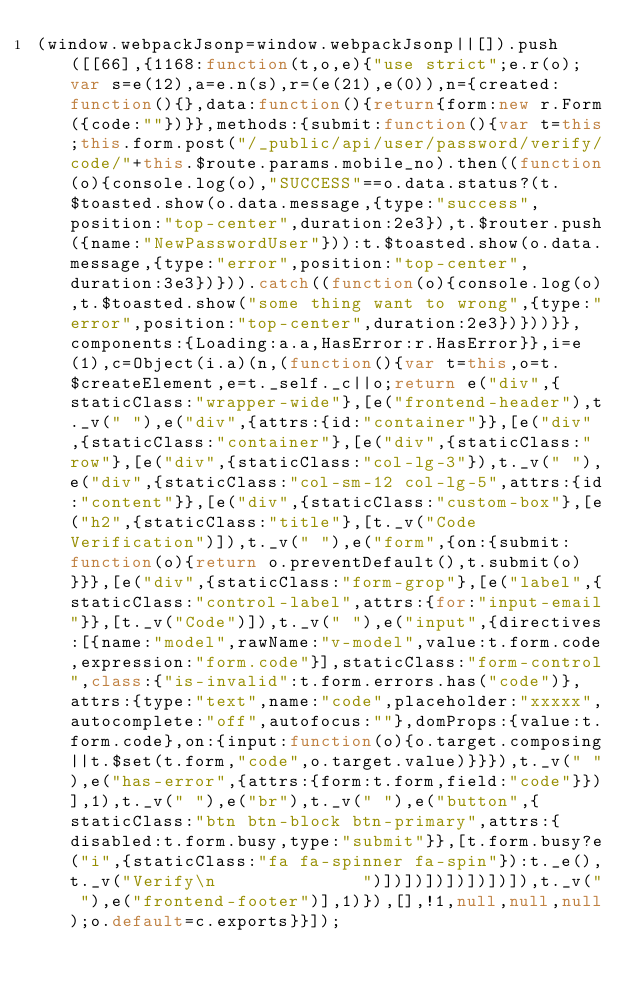Convert code to text. <code><loc_0><loc_0><loc_500><loc_500><_JavaScript_>(window.webpackJsonp=window.webpackJsonp||[]).push([[66],{1168:function(t,o,e){"use strict";e.r(o);var s=e(12),a=e.n(s),r=(e(21),e(0)),n={created:function(){},data:function(){return{form:new r.Form({code:""})}},methods:{submit:function(){var t=this;this.form.post("/_public/api/user/password/verify/code/"+this.$route.params.mobile_no).then((function(o){console.log(o),"SUCCESS"==o.data.status?(t.$toasted.show(o.data.message,{type:"success",position:"top-center",duration:2e3}),t.$router.push({name:"NewPasswordUser"})):t.$toasted.show(o.data.message,{type:"error",position:"top-center",duration:3e3})})).catch((function(o){console.log(o),t.$toasted.show("some thing want to wrong",{type:"error",position:"top-center",duration:2e3})}))}},components:{Loading:a.a,HasError:r.HasError}},i=e(1),c=Object(i.a)(n,(function(){var t=this,o=t.$createElement,e=t._self._c||o;return e("div",{staticClass:"wrapper-wide"},[e("frontend-header"),t._v(" "),e("div",{attrs:{id:"container"}},[e("div",{staticClass:"container"},[e("div",{staticClass:"row"},[e("div",{staticClass:"col-lg-3"}),t._v(" "),e("div",{staticClass:"col-sm-12 col-lg-5",attrs:{id:"content"}},[e("div",{staticClass:"custom-box"},[e("h2",{staticClass:"title"},[t._v("Code Verification")]),t._v(" "),e("form",{on:{submit:function(o){return o.preventDefault(),t.submit(o)}}},[e("div",{staticClass:"form-grop"},[e("label",{staticClass:"control-label",attrs:{for:"input-email"}},[t._v("Code")]),t._v(" "),e("input",{directives:[{name:"model",rawName:"v-model",value:t.form.code,expression:"form.code"}],staticClass:"form-control",class:{"is-invalid":t.form.errors.has("code")},attrs:{type:"text",name:"code",placeholder:"xxxxx",autocomplete:"off",autofocus:""},domProps:{value:t.form.code},on:{input:function(o){o.target.composing||t.$set(t.form,"code",o.target.value)}}}),t._v(" "),e("has-error",{attrs:{form:t.form,field:"code"}})],1),t._v(" "),e("br"),t._v(" "),e("button",{staticClass:"btn btn-block btn-primary",attrs:{disabled:t.form.busy,type:"submit"}},[t.form.busy?e("i",{staticClass:"fa fa-spinner fa-spin"}):t._e(),t._v("Verify\n              ")])])])])])])]),t._v(" "),e("frontend-footer")],1)}),[],!1,null,null,null);o.default=c.exports}}]);</code> 